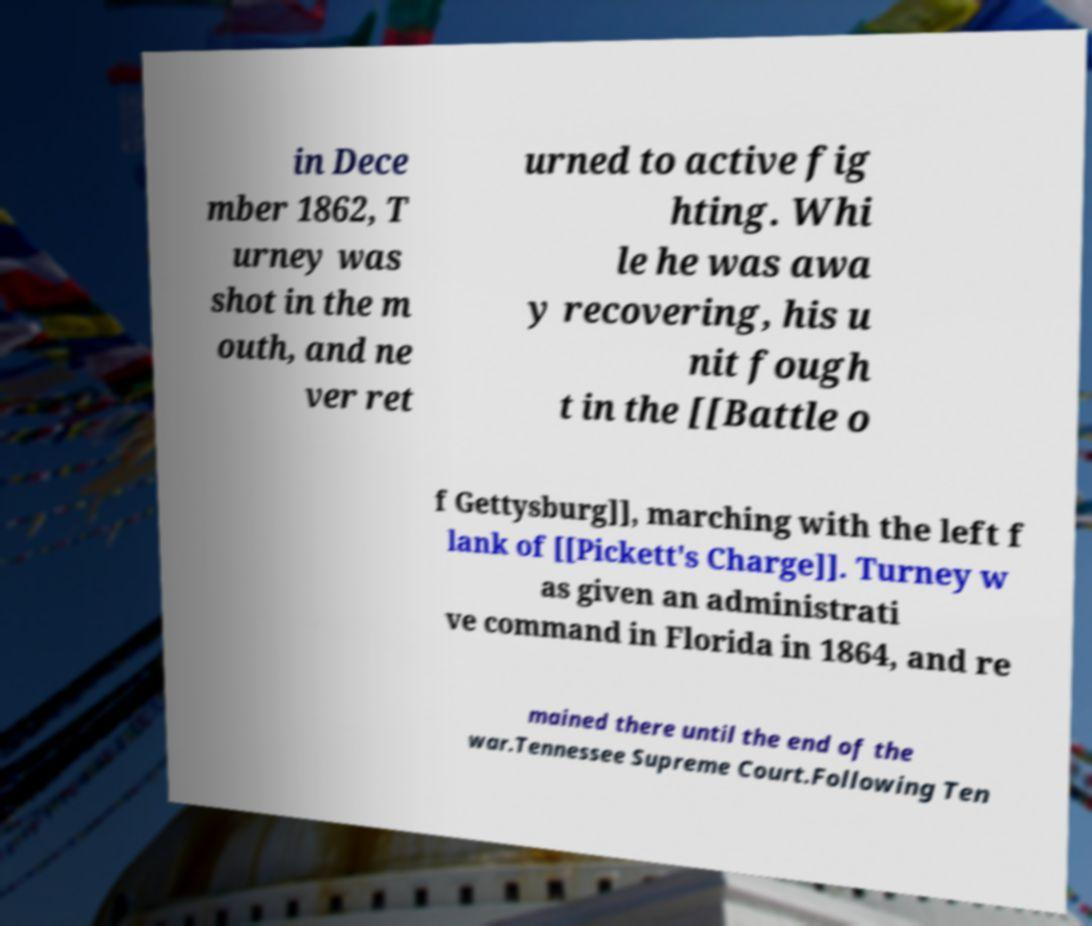Can you read and provide the text displayed in the image?This photo seems to have some interesting text. Can you extract and type it out for me? in Dece mber 1862, T urney was shot in the m outh, and ne ver ret urned to active fig hting. Whi le he was awa y recovering, his u nit fough t in the [[Battle o f Gettysburg]], marching with the left f lank of [[Pickett's Charge]]. Turney w as given an administrati ve command in Florida in 1864, and re mained there until the end of the war.Tennessee Supreme Court.Following Ten 